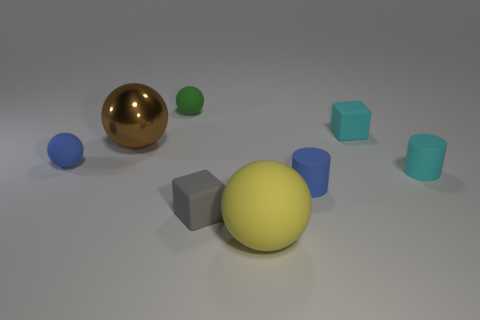Subtract all green rubber balls. How many balls are left? 3 Add 1 big green shiny objects. How many objects exist? 9 Subtract all purple spheres. Subtract all yellow cylinders. How many spheres are left? 4 Subtract 0 purple spheres. How many objects are left? 8 Subtract all large green blocks. Subtract all tiny blue rubber things. How many objects are left? 6 Add 1 cyan objects. How many cyan objects are left? 3 Add 3 purple blocks. How many purple blocks exist? 3 